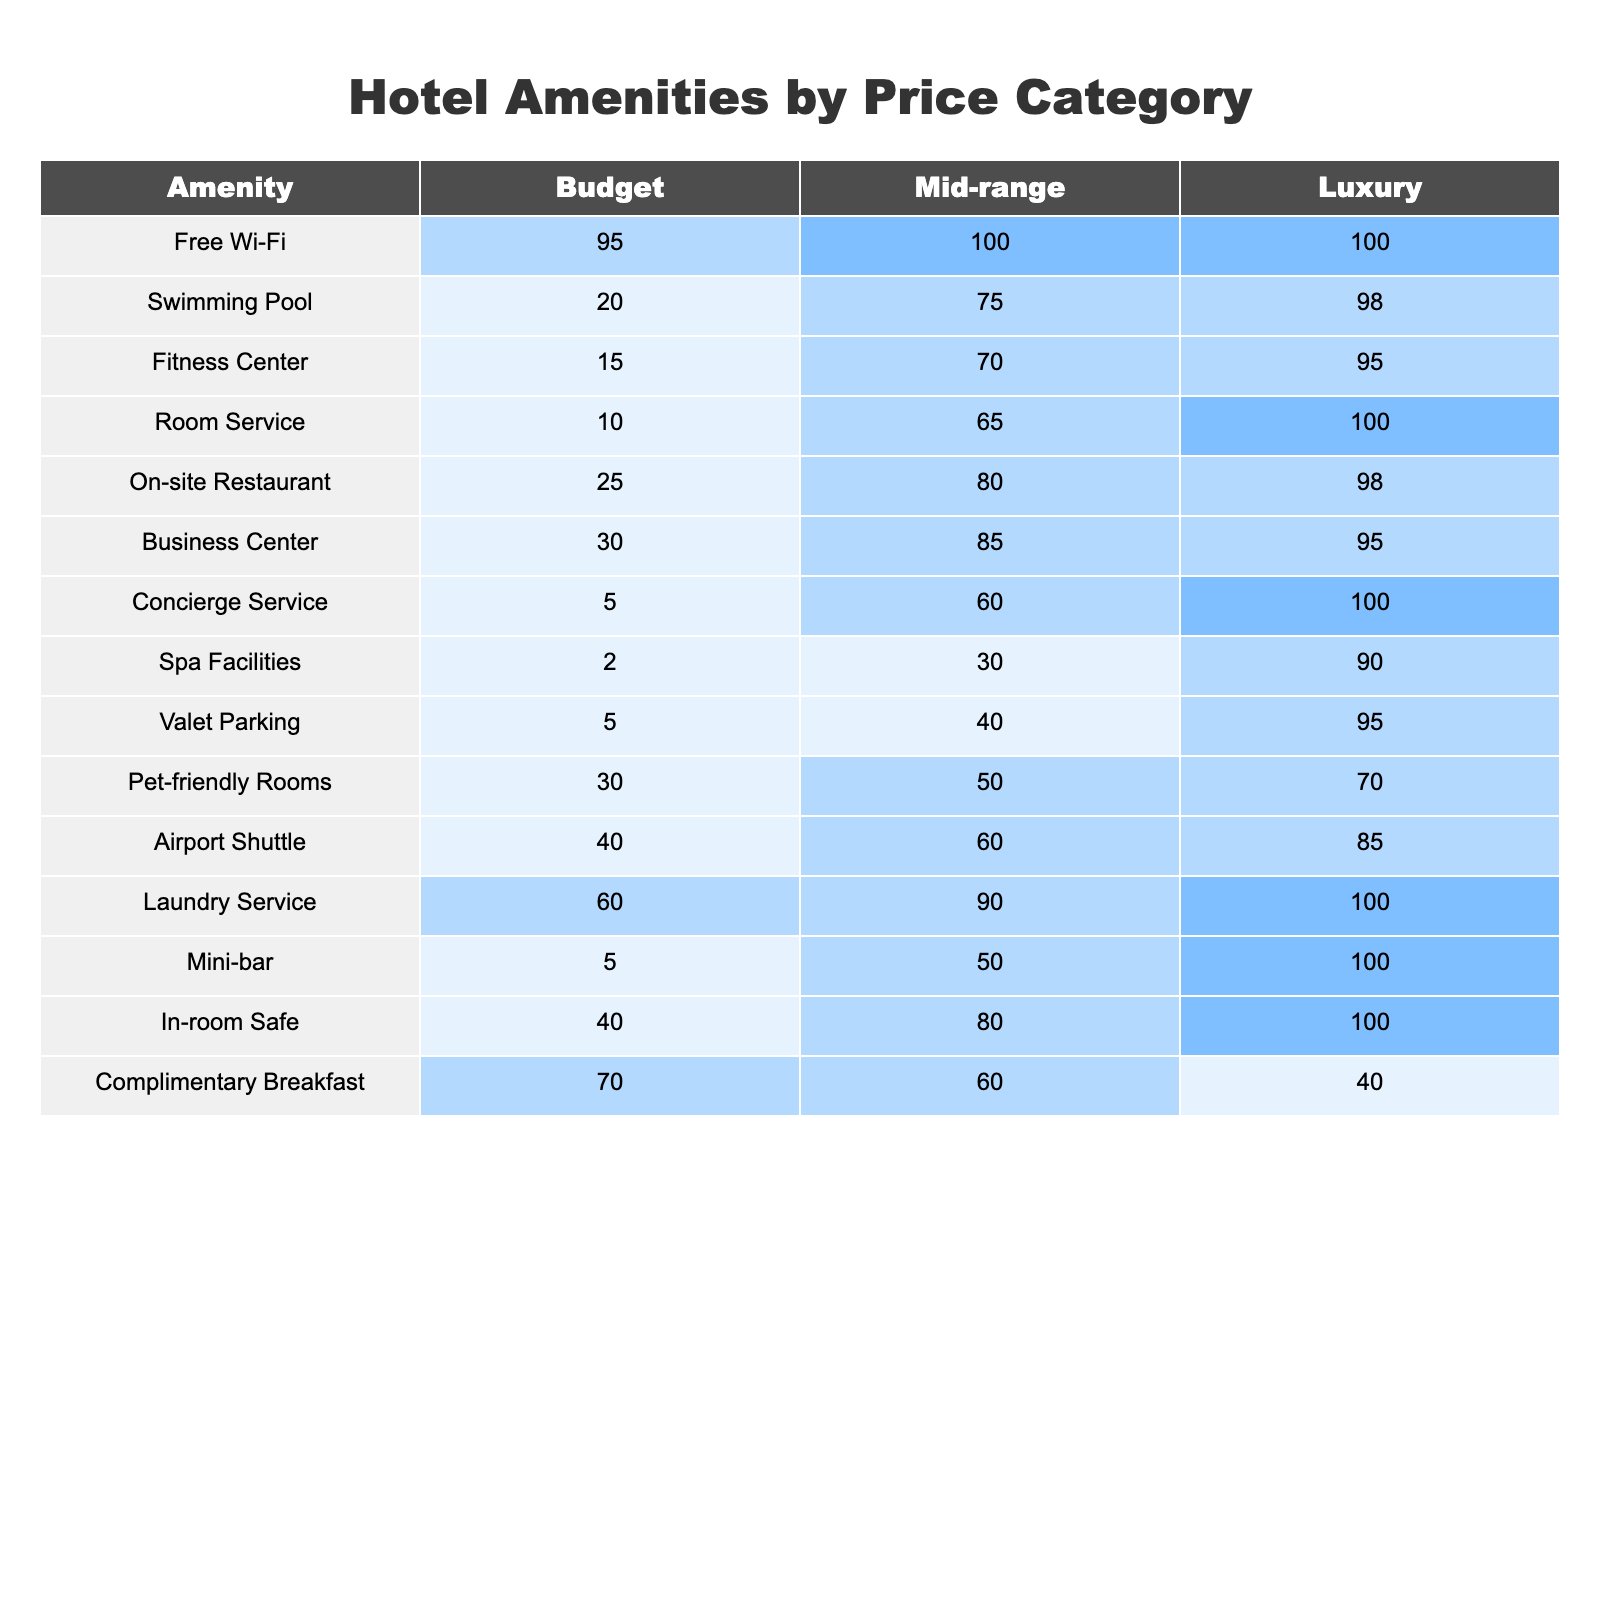What percentage of luxury hotels offer free Wi-Fi? According to the table, 100% of luxury hotels provide free Wi-Fi, as indicated in the 'Luxury' column for the 'Free Wi-Fi' row.
Answer: 100% Which amenity has the lowest percentage offering in budget hotels? From the table, the amenity with the lowest percentage in budget hotels is 'Spa Facilities,' with 2% availability, as noted in the corresponding row.
Answer: 2% What is the average percentage of mid-range hotels offering fitness centers and swimming pools? The percentage of mid-range hotels offering fitness centers is 70% and for swimming pools, it is 75%. The average is calculated as (70 + 75) / 2 = 72.5%.
Answer: 72.5% Are more luxury hotels or budget hotels offering valet parking? The table shows that 95% of luxury hotels offer valet parking compared to 5% of budget hotels, indicating that more luxury hotels provide this amenity.
Answer: Yes What is the percentage difference in the availability of room service between mid-range and luxury hotels? The table indicates that 65% of mid-range hotels and 100% of luxury hotels offer room service. The percentage difference is 100% - 65% = 35%.
Answer: 35% Which amenity is most commonly offered among budget hotels, and what percentage do they offer it? According to the table, 'Free Wi-Fi' is the most commonly offered amenity among budget hotels at 95%.
Answer: 95% If a hotel is mid-range, what is the probability it offers both an on-site restaurant and a business center? The table shows an on-site restaurant availability of 80% and a business center of 85% for mid-range hotels. The probability of offering both is 0.80 * 0.85 = 0.68 or 68%.
Answer: 68% How many more percentage points of luxury hotels provide complimentary breakfast compared to mid-range hotels? The table shows that luxury hotels provide complimentary breakfast at 40% against mid-range hotels at 60%. Thus, mid-range hotels offer 20% more than luxury hotels.
Answer: 20% Which category of hotels offers the highest percentage of pet-friendly rooms? The table indicates that 70% of luxury hotels offer pet-friendly rooms, which is higher than the corresponding values for budget and mid-range categories.
Answer: Luxury hotels What percentage of budget hotels have both laundry service and in-room safes? Looking at the table, 60% of budget hotels offer laundry service and 40% offer in-room safes. The percentage of budget hotels offering both amenities is 60% * 40% = 24%.
Answer: 24% 